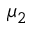Convert formula to latex. <formula><loc_0><loc_0><loc_500><loc_500>\mu _ { 2 }</formula> 